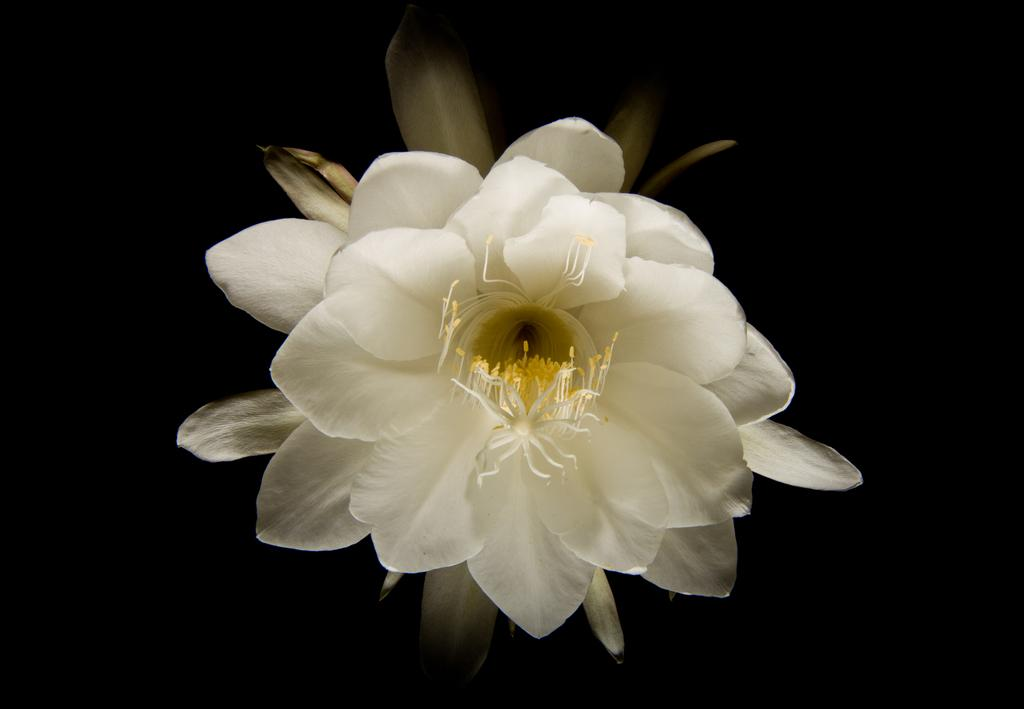What is the main subject of the image? There is a flower in the image. What time of day is it in the image? The time of day cannot be determined from the image, as it only features a flower. Can you see a worm crawling on the flower in the image? There is no worm present in the image; it only features a flower. 